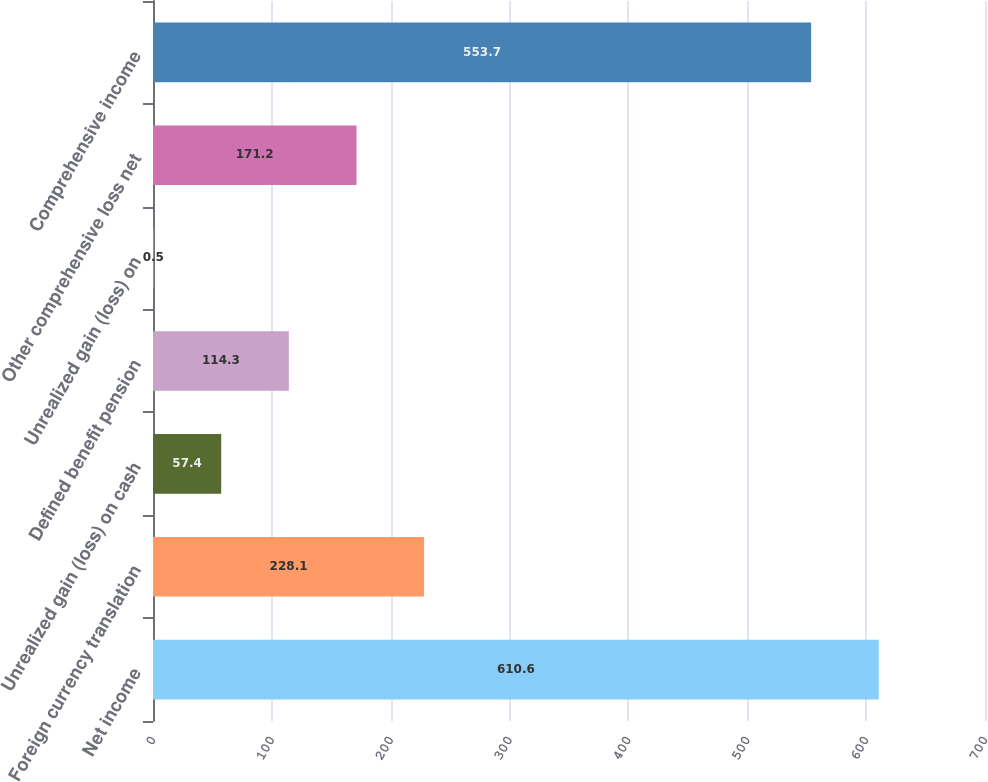<chart> <loc_0><loc_0><loc_500><loc_500><bar_chart><fcel>Net income<fcel>Foreign currency translation<fcel>Unrealized gain (loss) on cash<fcel>Defined benefit pension<fcel>Unrealized gain (loss) on<fcel>Other comprehensive loss net<fcel>Comprehensive income<nl><fcel>610.6<fcel>228.1<fcel>57.4<fcel>114.3<fcel>0.5<fcel>171.2<fcel>553.7<nl></chart> 